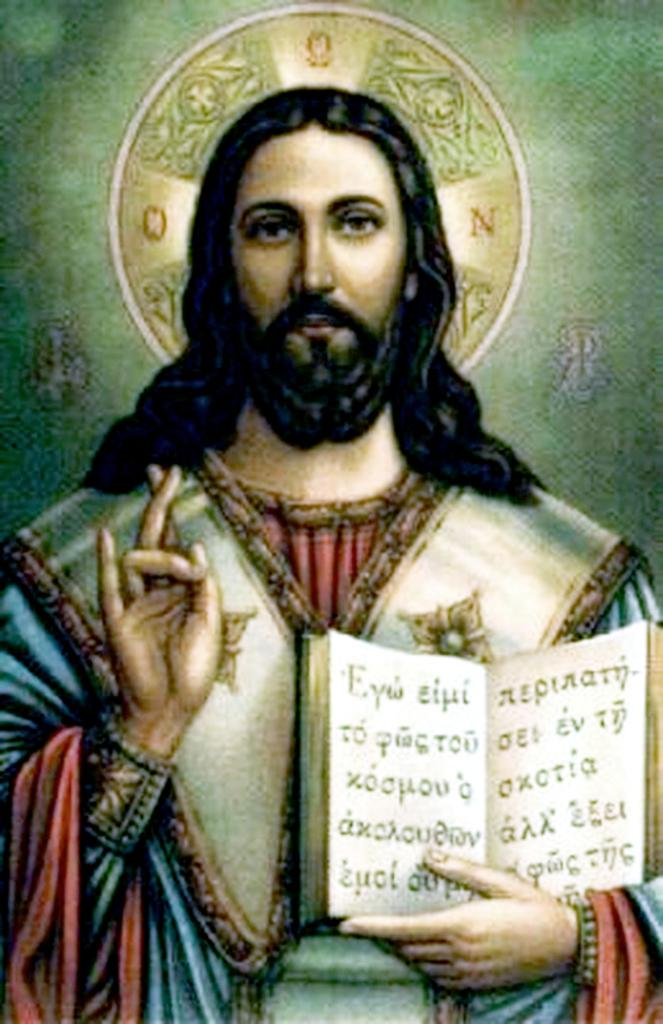What is present in the image? There is a person in the image. What is the person holding? The person is holding a book. What type of news can be heard from the giants in the image? There are no giants or news present in the image; it only features a person holding a book. What kind of cracker is the person eating in the image? There is no cracker present in the image; the person is holding a book. 